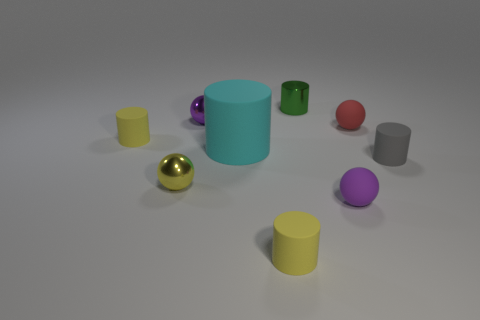Subtract all green cylinders. How many cylinders are left? 4 Subtract all tiny gray cylinders. How many cylinders are left? 4 Subtract all purple cylinders. Subtract all red blocks. How many cylinders are left? 5 Add 1 tiny purple matte spheres. How many objects exist? 10 Subtract all spheres. How many objects are left? 5 Add 9 tiny purple matte spheres. How many tiny purple matte spheres exist? 10 Subtract 0 brown cubes. How many objects are left? 9 Subtract all small yellow cylinders. Subtract all tiny metal cylinders. How many objects are left? 6 Add 5 big matte cylinders. How many big matte cylinders are left? 6 